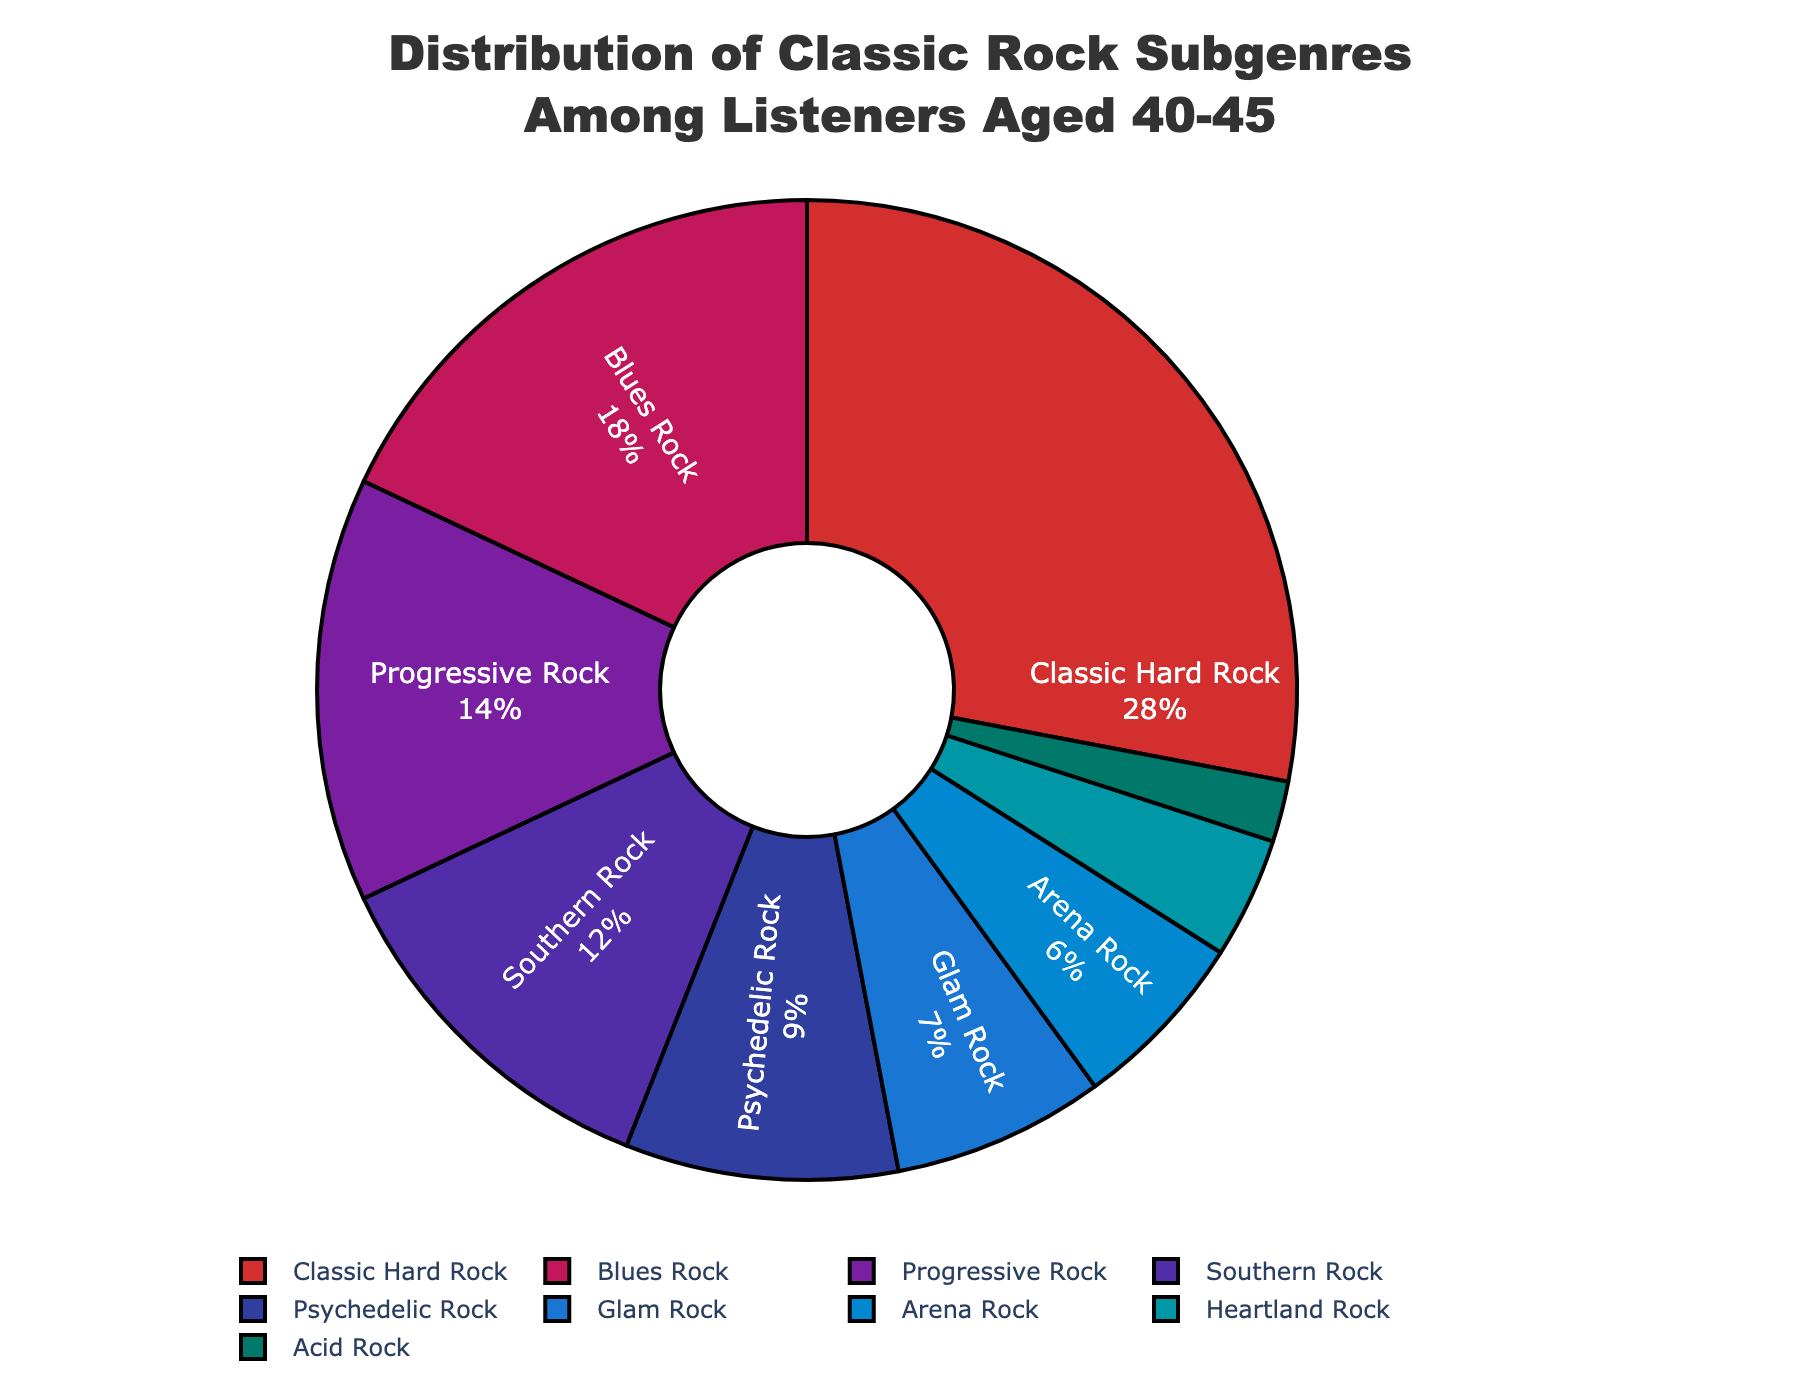What's the percentage of listeners who prefer Progressive Rock and Southern Rock combined? To find the combined percentage, add the individual percentages of Progressive Rock (14%) and Southern Rock (12%). Therefore, the combined percentage is 14% + 12% = 26%.
Answer: 26% Which subgenre is more popular, Psychedelic Rock or Blues Rock? Compare the percentages of Psychedelic Rock (9%) and Blues Rock (18%). Since 18% (Blues Rock) is greater than 9% (Psychedelic Rock), Blues Rock is more popular.
Answer: Blues Rock Among Classic Hard Rock, Blues Rock, and Progressive Rock, which one has the highest percentage? Compare the percentages of Classic Hard Rock (28%), Blues Rock (18%), and Progressive Rock (14%). Classic Hard Rock has the highest percentage at 28%.
Answer: Classic Hard Rock What is the total percentage of listeners who prefer either Arena Rock or Heartland Rock? To find the total percentage, add the individual percentages of Arena Rock (6%) and Heartland Rock (4%). The total is 6% + 4% = 10%.
Answer: 10% What is the difference in popularity between Classic Hard Rock and Acid Rock? Subtract the percentage of Acid Rock (2%) from the percentage of Classic Hard Rock (28%). The difference is 28% - 2% = 26%.
Answer: 26% Which subgenre has the smallest percentage of listeners? By examining the percentages, Acid Rock has the smallest percentage at 2%.
Answer: Acid Rock Is the percentage of listeners who prefer Southern Rock greater than those who prefer Glam Rock? Compare the percentages of Southern Rock (12%) and Glam Rock (7%). Since 12% (Southern Rock) is greater than 7% (Glam Rock), the answer is yes.
Answer: Yes What is the combined percentage of listeners who prefer Glam Rock, Arena Rock, and Heartland Rock? Add the percentages of Glam Rock (7%), Arena Rock (6%), and Heartland Rock (4%) to get the combined percentage. The total is 7% + 6% + 4% = 17%.
Answer: 17% Which subgenre is represented by the color red in the pie chart? Since the first color in the list corresponds to Classic Hard Rock and the first color is red, Classic Hard Rock is represented by the color red.
Answer: Classic Hard Rock 